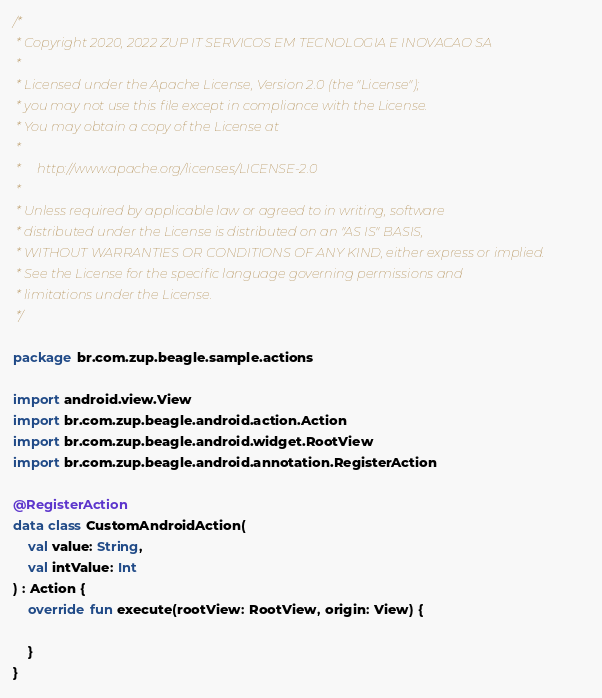Convert code to text. <code><loc_0><loc_0><loc_500><loc_500><_Kotlin_>/*
 * Copyright 2020, 2022 ZUP IT SERVICOS EM TECNOLOGIA E INOVACAO SA
 *
 * Licensed under the Apache License, Version 2.0 (the "License");
 * you may not use this file except in compliance with the License.
 * You may obtain a copy of the License at
 *
 *     http://www.apache.org/licenses/LICENSE-2.0
 *
 * Unless required by applicable law or agreed to in writing, software
 * distributed under the License is distributed on an "AS IS" BASIS,
 * WITHOUT WARRANTIES OR CONDITIONS OF ANY KIND, either express or implied.
 * See the License for the specific language governing permissions and
 * limitations under the License.
 */

package br.com.zup.beagle.sample.actions

import android.view.View
import br.com.zup.beagle.android.action.Action
import br.com.zup.beagle.android.widget.RootView
import br.com.zup.beagle.android.annotation.RegisterAction

@RegisterAction
data class CustomAndroidAction(
    val value: String,
    val intValue: Int
) : Action {
    override fun execute(rootView: RootView, origin: View) {

    }
}</code> 